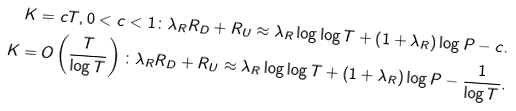<formula> <loc_0><loc_0><loc_500><loc_500>K = c T , 0 < c < 1 \colon \lambda _ { R } R _ { D } + R _ { U } \approx \lambda _ { R } \log \log T + \left ( 1 + \lambda _ { R } \right ) \log P - c . \\ K = O \left ( \frac { T } { \log T } \right ) \colon \lambda _ { R } R _ { D } + R _ { U } \approx \lambda _ { R } \log \log T + \left ( 1 + \lambda _ { R } \right ) \log P - \frac { 1 } { \log T } .</formula> 